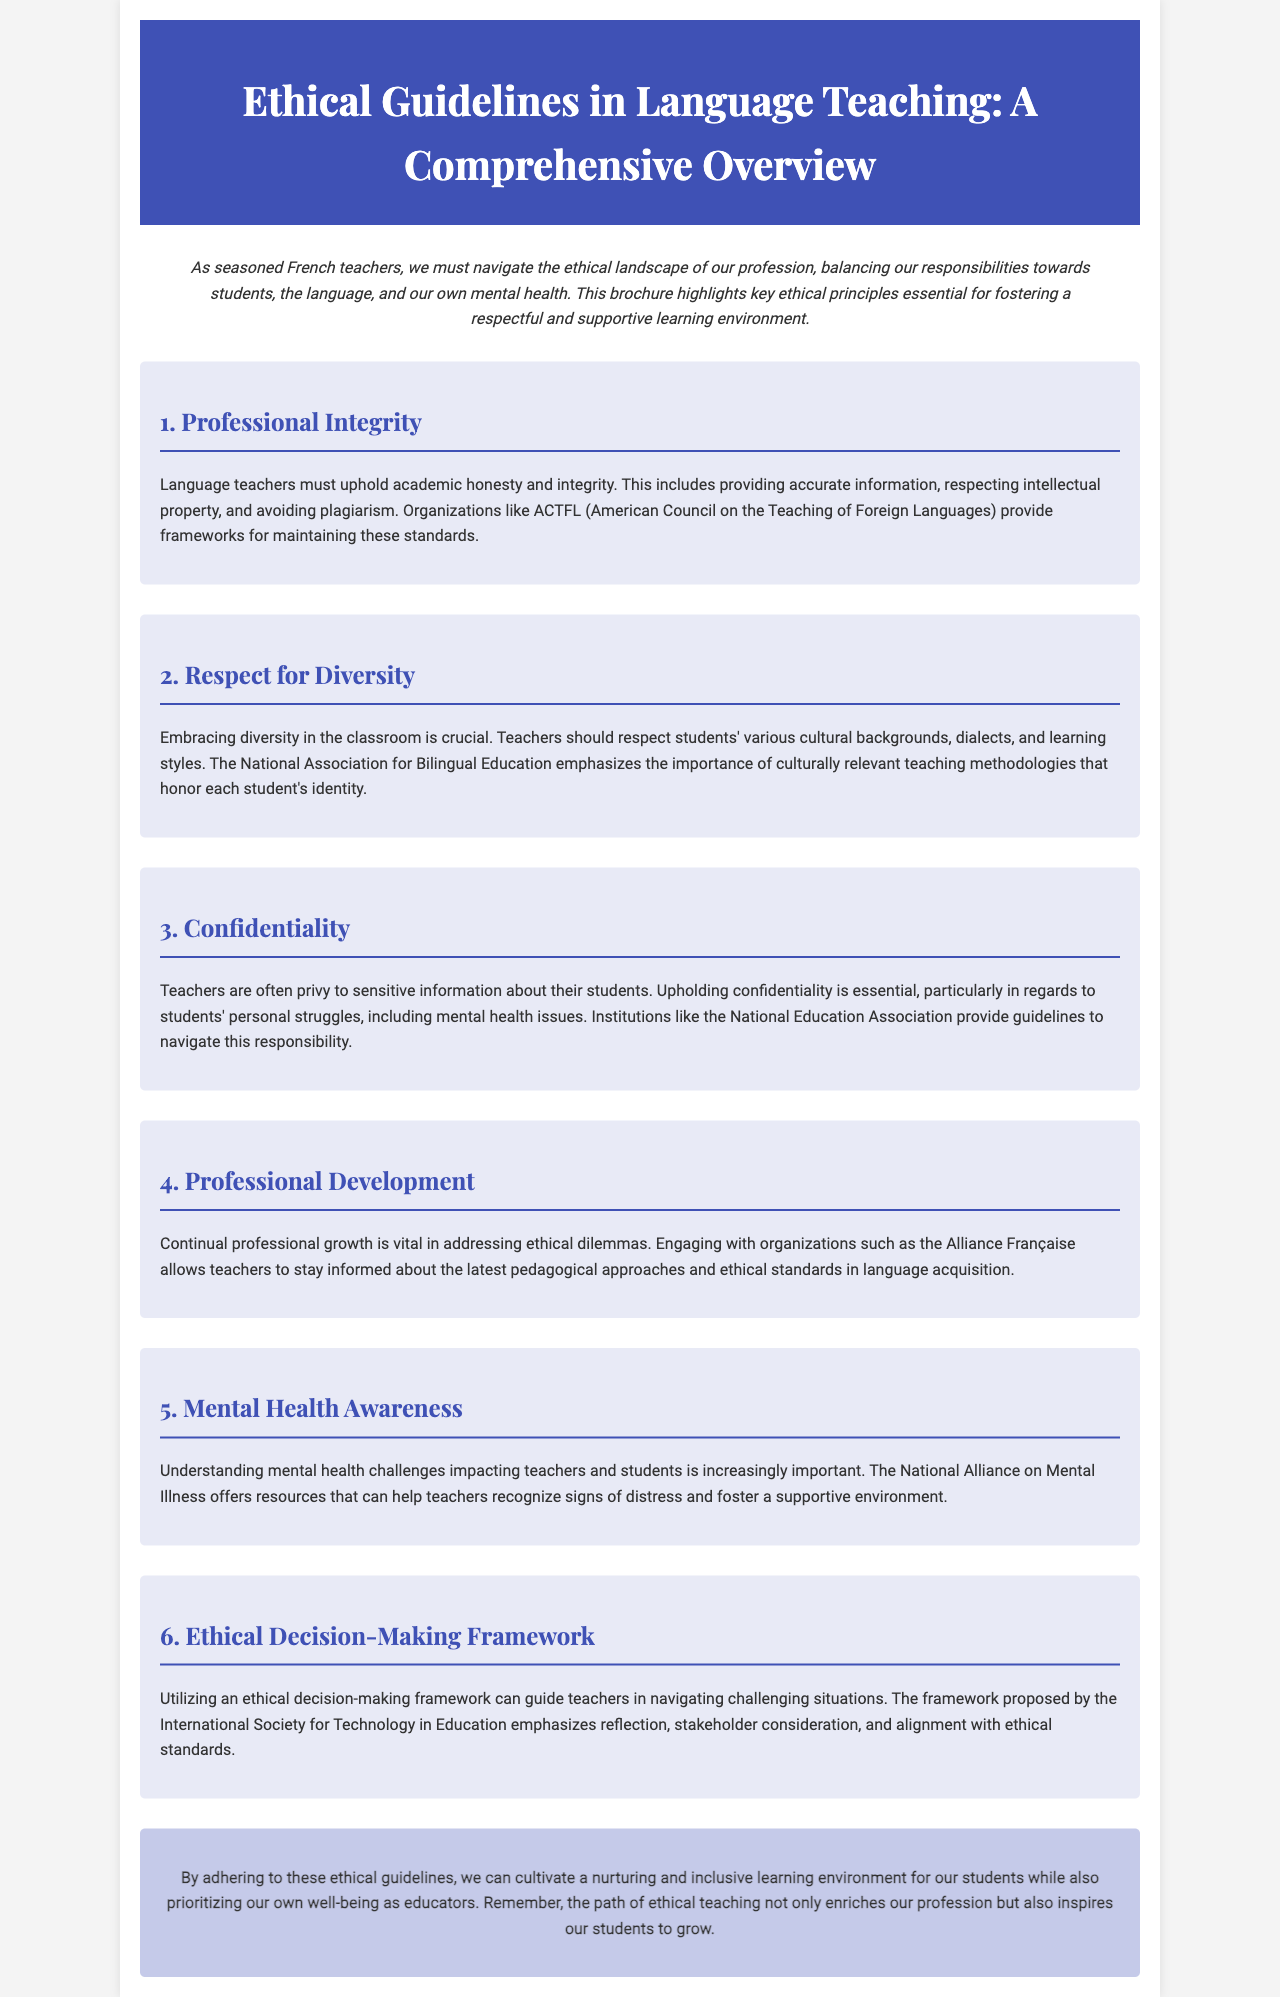What is the title of the brochure? The title is stated in the header section of the document.
Answer: Ethical Guidelines in Language Teaching: A Comprehensive Overview What organization provides frameworks for maintaining professional integrity? This information is mentioned in the section about Professional Integrity.
Answer: ACTFL What does the brochure emphasize the importance of in teaching methodologies? It is highlighted in the Respect for Diversity section of the document.
Answer: Culturally relevant teaching methodologies What is essential for teachers regarding students' sensitive information? This aspect is discussed in the Confidentiality section.
Answer: Upholding confidentiality Which organization helps recognize signs of mental distress? This is found in the Mental Health Awareness section of the brochure.
Answer: National Alliance on Mental Illness What is the focus of the Professional Development section? The section discusses the importance of continual professional growth for teachers.
Answer: Continual professional growth What ethical aspect does the framework by the International Society for Technology in Education cover? This is explained in the Ethical Decision-Making Framework section.
Answer: Reflection, stakeholder consideration, and alignment with ethical standards What is the main goal of adhering to the ethical guidelines? The concluding section outlines the purpose of following these guidelines.
Answer: Cultivating a nurturing and inclusive learning environment 